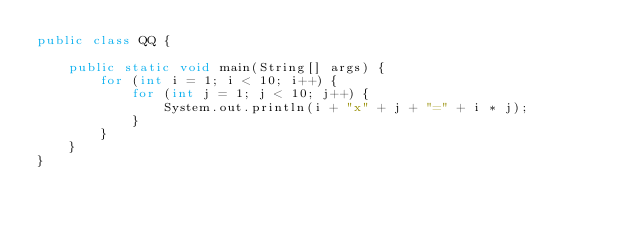<code> <loc_0><loc_0><loc_500><loc_500><_Java_>public class QQ {

    public static void main(String[] args) {
        for (int i = 1; i < 10; i++) {
            for (int j = 1; j < 10; j++) {
                System.out.println(i + "x" + j + "=" + i * j);
            }
        }
    }
}</code> 